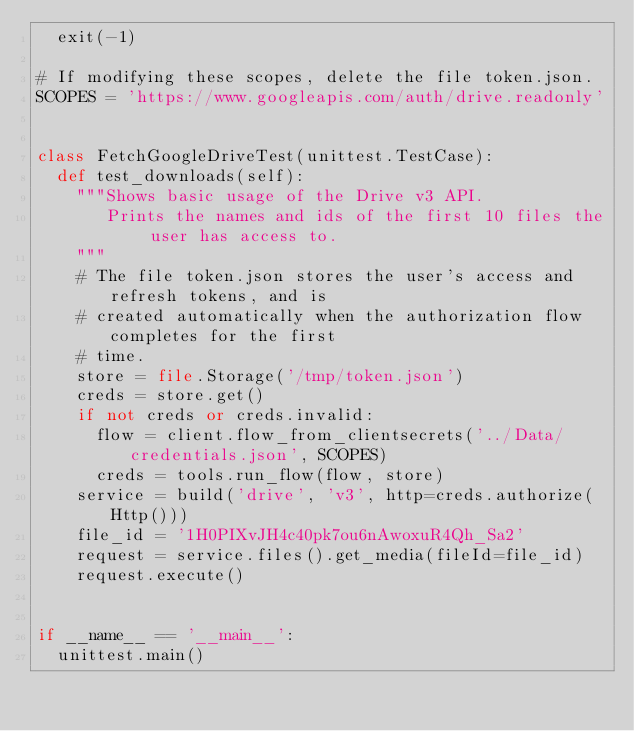Convert code to text. <code><loc_0><loc_0><loc_500><loc_500><_Python_>  exit(-1)

# If modifying these scopes, delete the file token.json.
SCOPES = 'https://www.googleapis.com/auth/drive.readonly'


class FetchGoogleDriveTest(unittest.TestCase):
  def test_downloads(self):
    """Shows basic usage of the Drive v3 API.
       Prints the names and ids of the first 10 files the user has access to.
    """
    # The file token.json stores the user's access and refresh tokens, and is
    # created automatically when the authorization flow completes for the first
    # time.
    store = file.Storage('/tmp/token.json')
    creds = store.get()
    if not creds or creds.invalid:
      flow = client.flow_from_clientsecrets('../Data/credentials.json', SCOPES)
      creds = tools.run_flow(flow, store)
    service = build('drive', 'v3', http=creds.authorize(Http()))
    file_id = '1H0PIXvJH4c40pk7ou6nAwoxuR4Qh_Sa2'
    request = service.files().get_media(fileId=file_id)
    request.execute()


if __name__ == '__main__':
  unittest.main()
</code> 